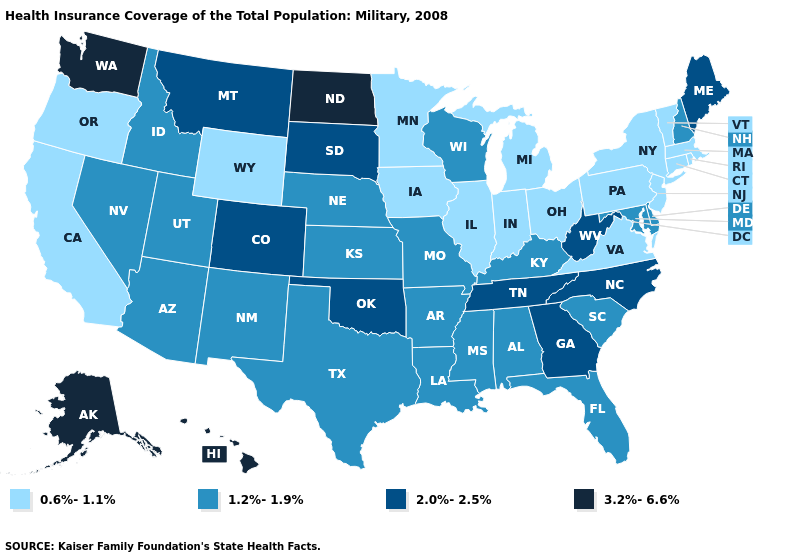Is the legend a continuous bar?
Keep it brief. No. What is the value of New Hampshire?
Be succinct. 1.2%-1.9%. Does California have the lowest value in the West?
Short answer required. Yes. What is the value of North Dakota?
Answer briefly. 3.2%-6.6%. Name the states that have a value in the range 2.0%-2.5%?
Answer briefly. Colorado, Georgia, Maine, Montana, North Carolina, Oklahoma, South Dakota, Tennessee, West Virginia. What is the value of Minnesota?
Keep it brief. 0.6%-1.1%. Which states have the lowest value in the Northeast?
Short answer required. Connecticut, Massachusetts, New Jersey, New York, Pennsylvania, Rhode Island, Vermont. Among the states that border Minnesota , which have the lowest value?
Answer briefly. Iowa. What is the value of Montana?
Be succinct. 2.0%-2.5%. Does North Dakota have the lowest value in the USA?
Short answer required. No. What is the highest value in the USA?
Answer briefly. 3.2%-6.6%. Name the states that have a value in the range 3.2%-6.6%?
Concise answer only. Alaska, Hawaii, North Dakota, Washington. Name the states that have a value in the range 0.6%-1.1%?
Short answer required. California, Connecticut, Illinois, Indiana, Iowa, Massachusetts, Michigan, Minnesota, New Jersey, New York, Ohio, Oregon, Pennsylvania, Rhode Island, Vermont, Virginia, Wyoming. Does Alaska have a higher value than Washington?
Concise answer only. No. Which states have the highest value in the USA?
Keep it brief. Alaska, Hawaii, North Dakota, Washington. 